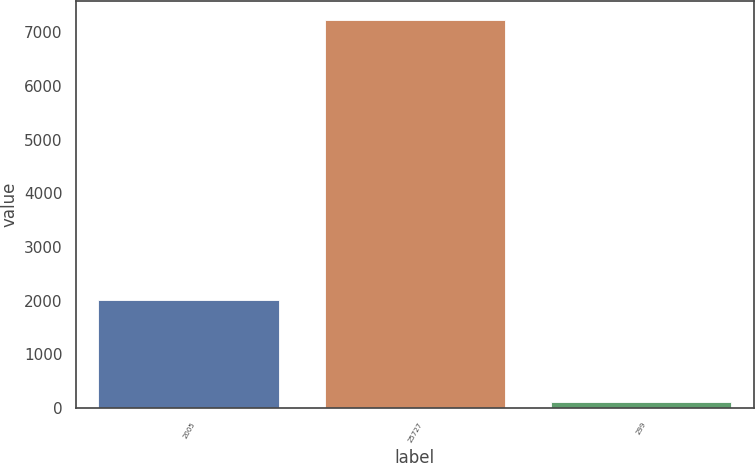Convert chart. <chart><loc_0><loc_0><loc_500><loc_500><bar_chart><fcel>2005<fcel>25727<fcel>299<nl><fcel>2003<fcel>7225<fcel>107<nl></chart> 